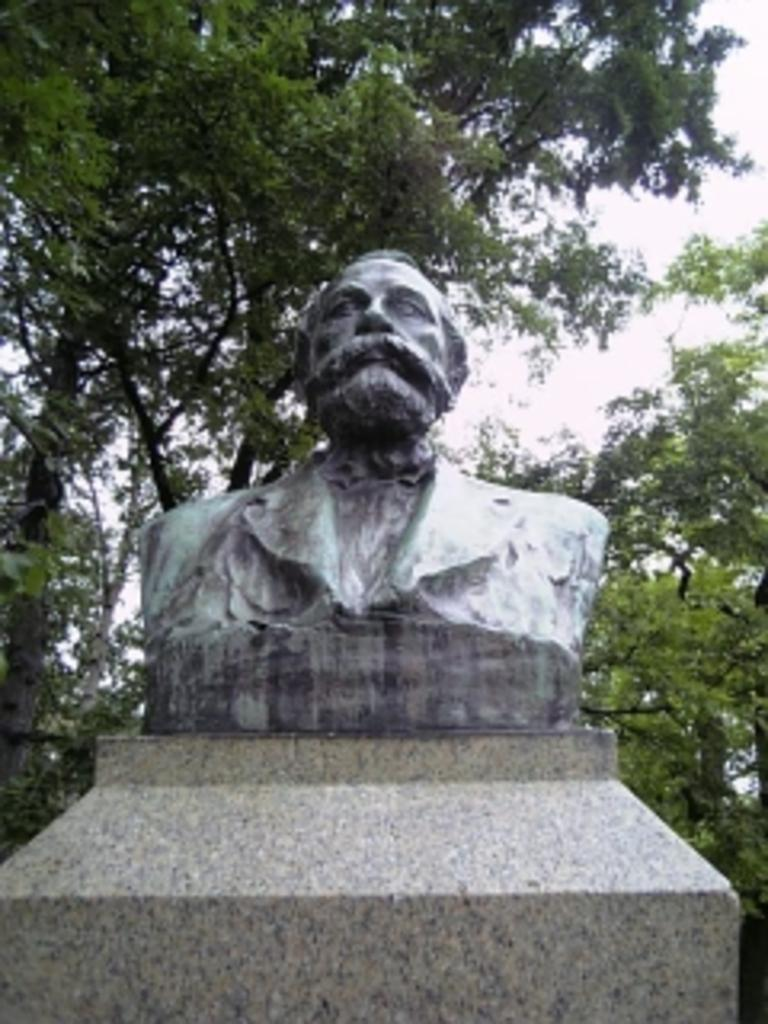What is the main subject of the image? There is a statue of a man in the image. What can be seen behind the statue? There are trees behind the statue in the image. What type of game is being played in the image? There is no game being played in the image; it features a statue of a man and trees in the background. What material is the statue made of? The provided facts do not mention the material of the statue, so we cannot determine if it is made of stone, brass, or any other material. 